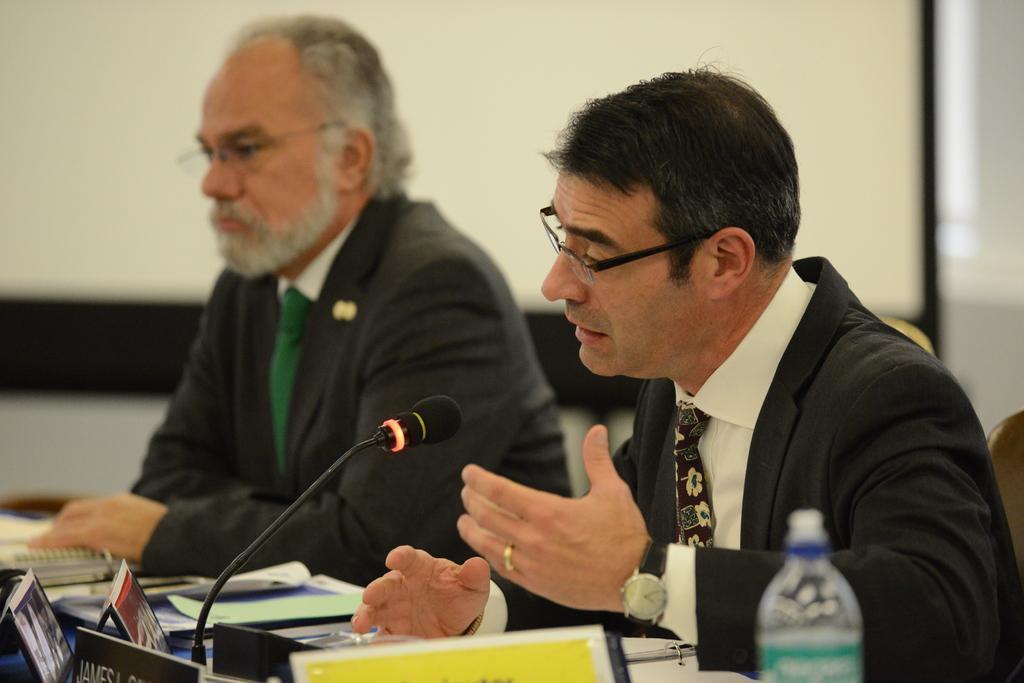Could you give a brief overview of what you see in this image? In this picture there is a man who is wearing spectacle, suit and watch. He is sitting on the chair, beside him there is a table. On the table we can see a name plates, mic, papers, books, water bottle, files and other objects. On the left there is another man who is wearing spectacles and suit. In the background there is a projector screen, beside that there is a wall. On the right background there is a window blind. 